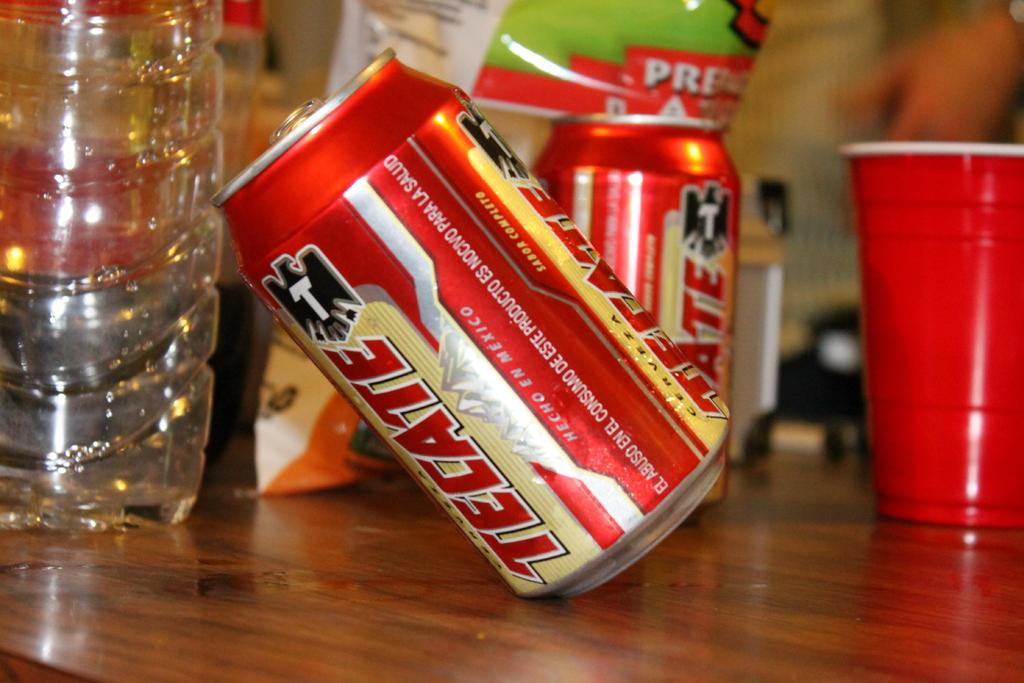<image>
Share a concise interpretation of the image provided. A red, silver and beige can of Tecate branded beer is tipped over. 